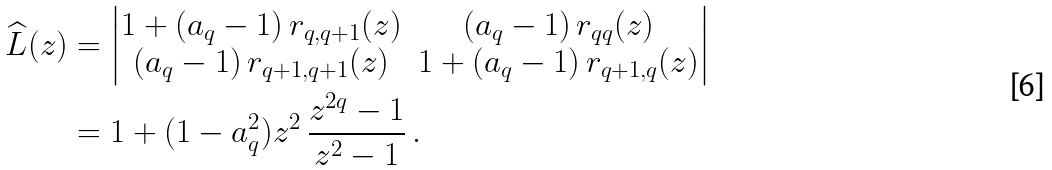Convert formula to latex. <formula><loc_0><loc_0><loc_500><loc_500>\widehat { L } ( z ) & = \begin{vmatrix} 1 + ( a _ { q } - 1 ) \, r _ { q , q + 1 } ( z ) & ( a _ { q } - 1 ) \, r _ { q q } ( z ) \\ ( a _ { q } - 1 ) \, r _ { q + 1 , q + 1 } ( z ) & 1 + ( a _ { q } - 1 ) \, r _ { q + 1 , q } ( z ) \end{vmatrix} \\ & = 1 + ( 1 - a _ { q } ^ { 2 } ) z ^ { 2 } \, \frac { z ^ { 2 q } - 1 } { z ^ { 2 } - 1 } \, .</formula> 